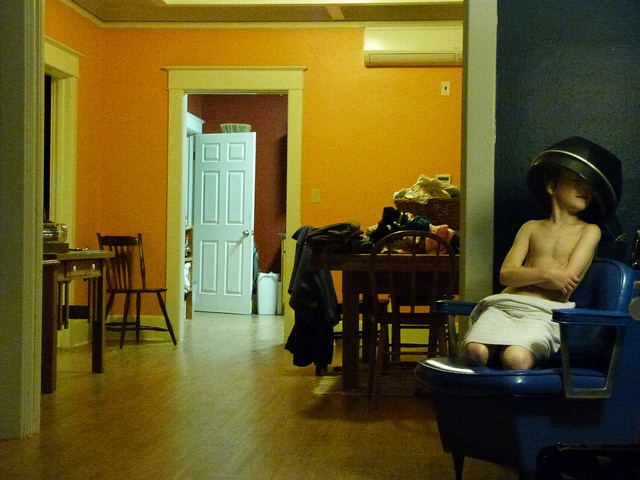Describe the objects in this image and their specific colors. I can see chair in darkgreen, black, navy, and blue tones, couch in darkgreen, black, navy, blue, and gray tones, people in darkgreen, tan, black, beige, and olive tones, chair in darkgreen, black, maroon, and olive tones, and dining table in darkgreen, black, olive, and maroon tones in this image. 